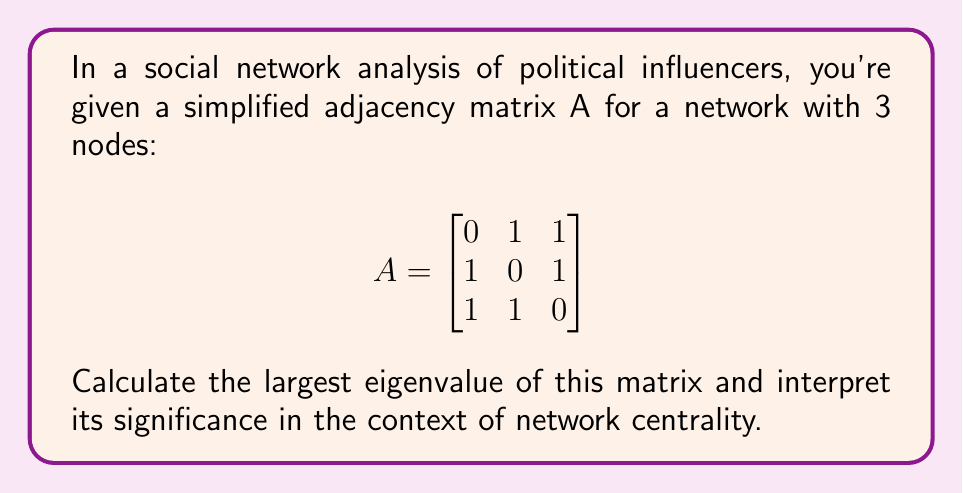Give your solution to this math problem. To find the eigenvalues of the adjacency matrix A, we need to solve the characteristic equation:

1. The characteristic equation is given by $\det(A - \lambda I) = 0$, where $\lambda$ represents the eigenvalues and I is the 3x3 identity matrix.

2. Expanding the determinant:
   $$\det\begin{bmatrix}
   -\lambda & 1 & 1 \\
   1 & -\lambda & 1 \\
   1 & 1 & -\lambda
   \end{bmatrix} = 0$$

3. Calculating the determinant:
   $-\lambda^3 + 3\lambda + 2 = 0$

4. This cubic equation can be factored as:
   $-(\lambda - 2)(\lambda^2 + 2\lambda - 1) = 0$

5. Solving this equation, we get the eigenvalues:
   $\lambda_1 = 2$
   $\lambda_2 = -1 - \sqrt{2}$
   $\lambda_3 = -1 + \sqrt{2}$

6. The largest eigenvalue is $\lambda_1 = 2$.

Interpretation: In network analysis, the largest eigenvalue (also known as the spectral radius) is related to the network's overall connectivity and the potential for information spread. A larger value indicates a more connected network with potentially faster information diffusion. In this case, the value of 2 suggests a moderately connected network of political influencers, which could be significant for understanding how political messages might propagate through the network.
Answer: $\lambda_1 = 2$ 